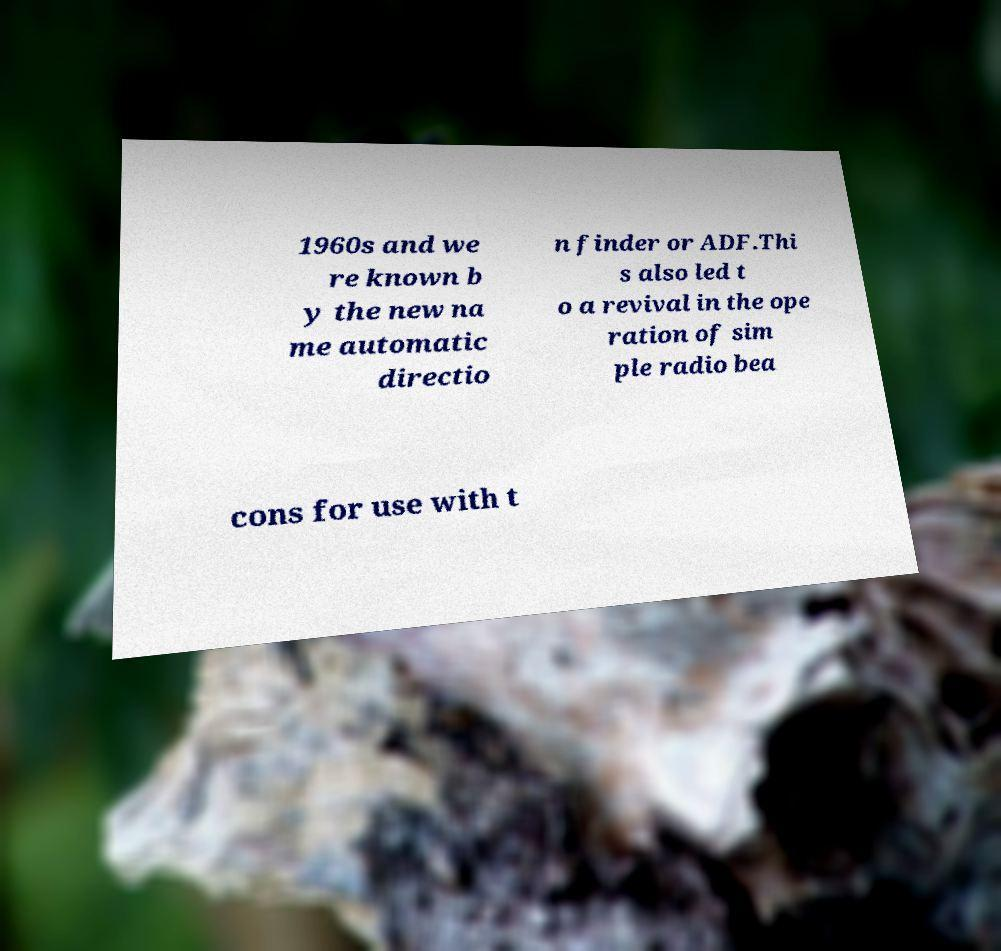What messages or text are displayed in this image? I need them in a readable, typed format. 1960s and we re known b y the new na me automatic directio n finder or ADF.Thi s also led t o a revival in the ope ration of sim ple radio bea cons for use with t 